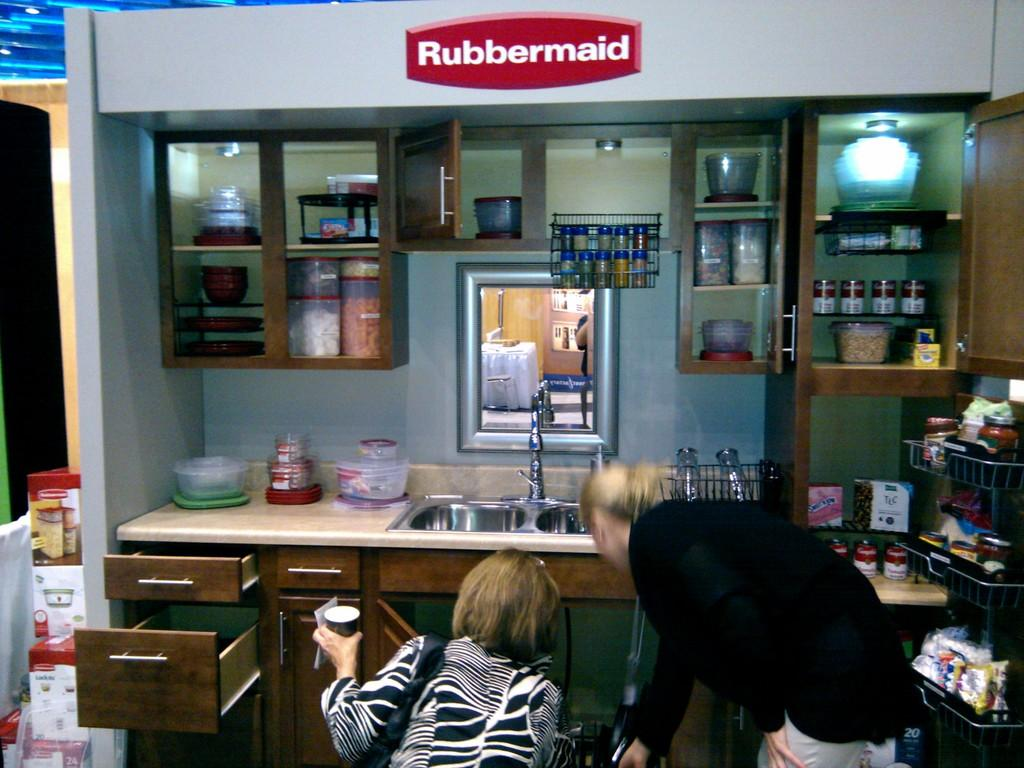What are the two people in the image doing? The two people in the image are bending on their legs. What are the two people looking at? The two people are looking at something. What can be seen in the background of the image? In the background of the image, there are kitchen groceries, a mirror, and a wash basin}. How many people are present in the image? There are two people present in the image. What tool are the two people using to measure the distance between them in the image? There is no tool visible in the image for measuring distance between the two people. 